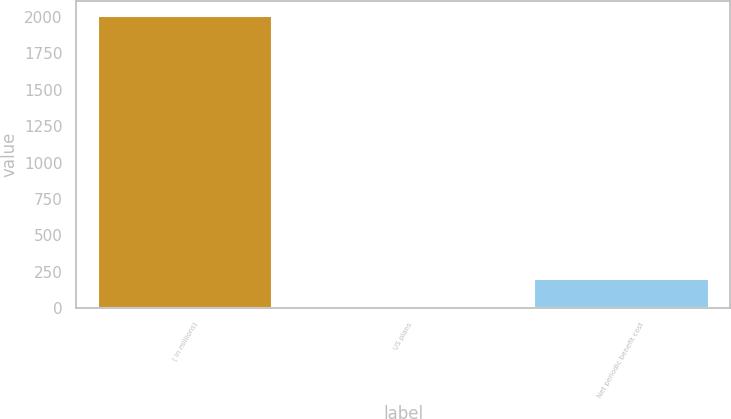Convert chart to OTSL. <chart><loc_0><loc_0><loc_500><loc_500><bar_chart><fcel>( in millions)<fcel>US plans<fcel>Net periodic benefit cost<nl><fcel>2008<fcel>1.7<fcel>202.33<nl></chart> 